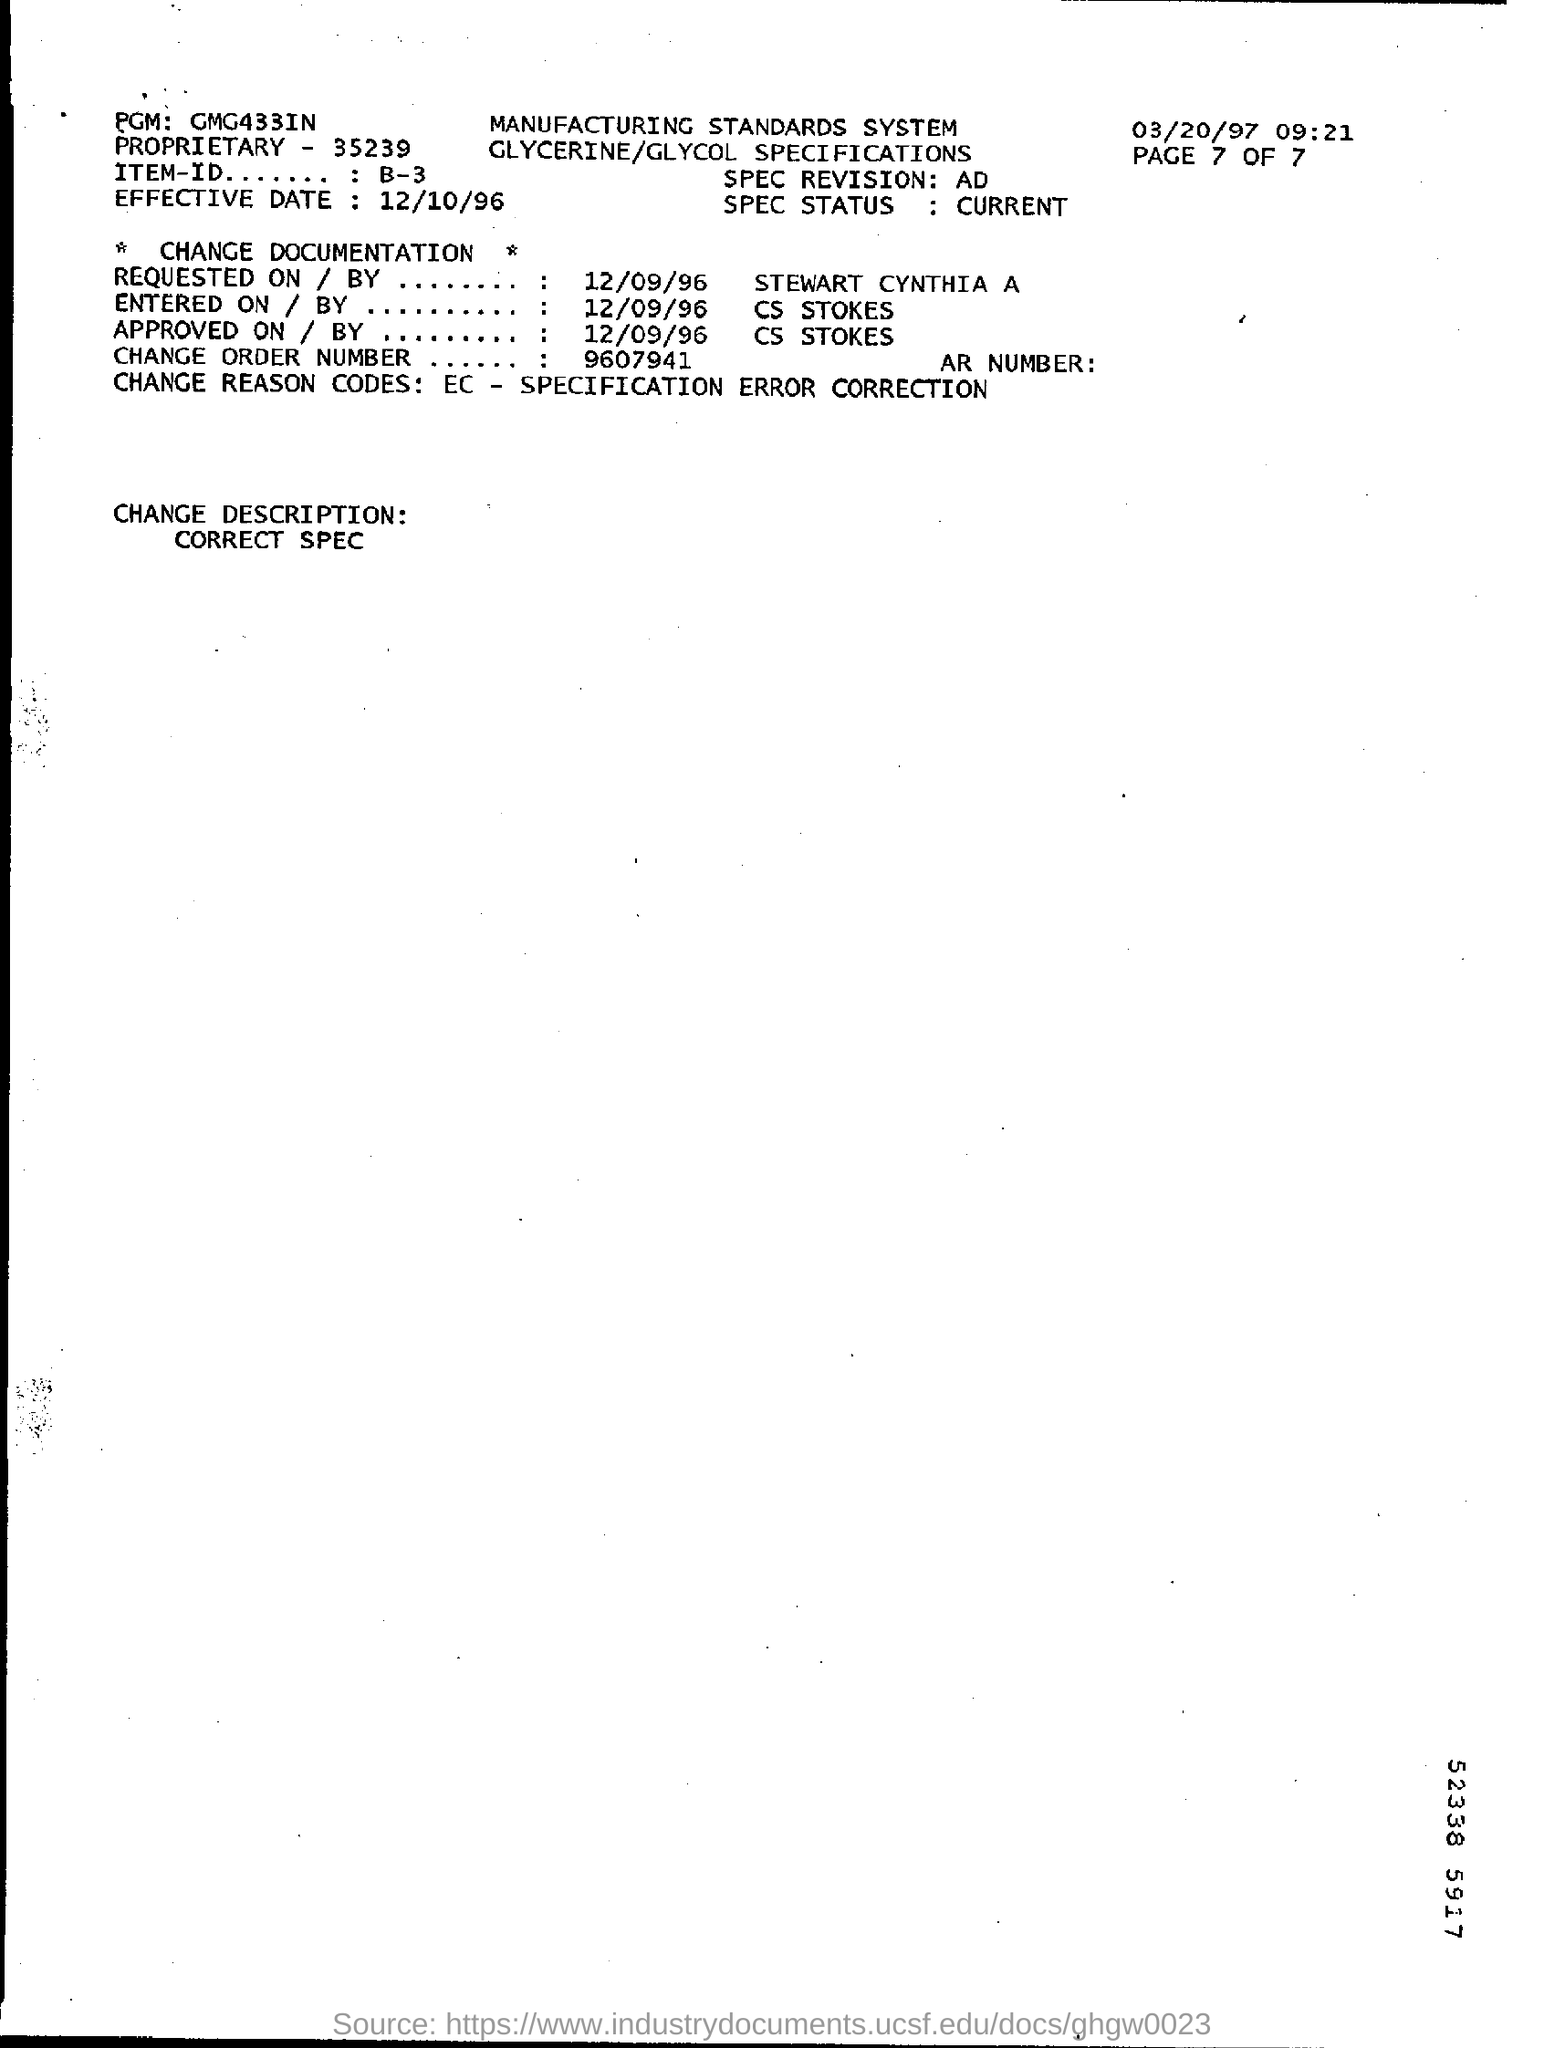Draw attention to some important aspects in this diagram. The approval of the change documentation was authorized by CS Stokes. On December 9th, 1996, the request for change documentation was made. What is the current status of the SPEC? 